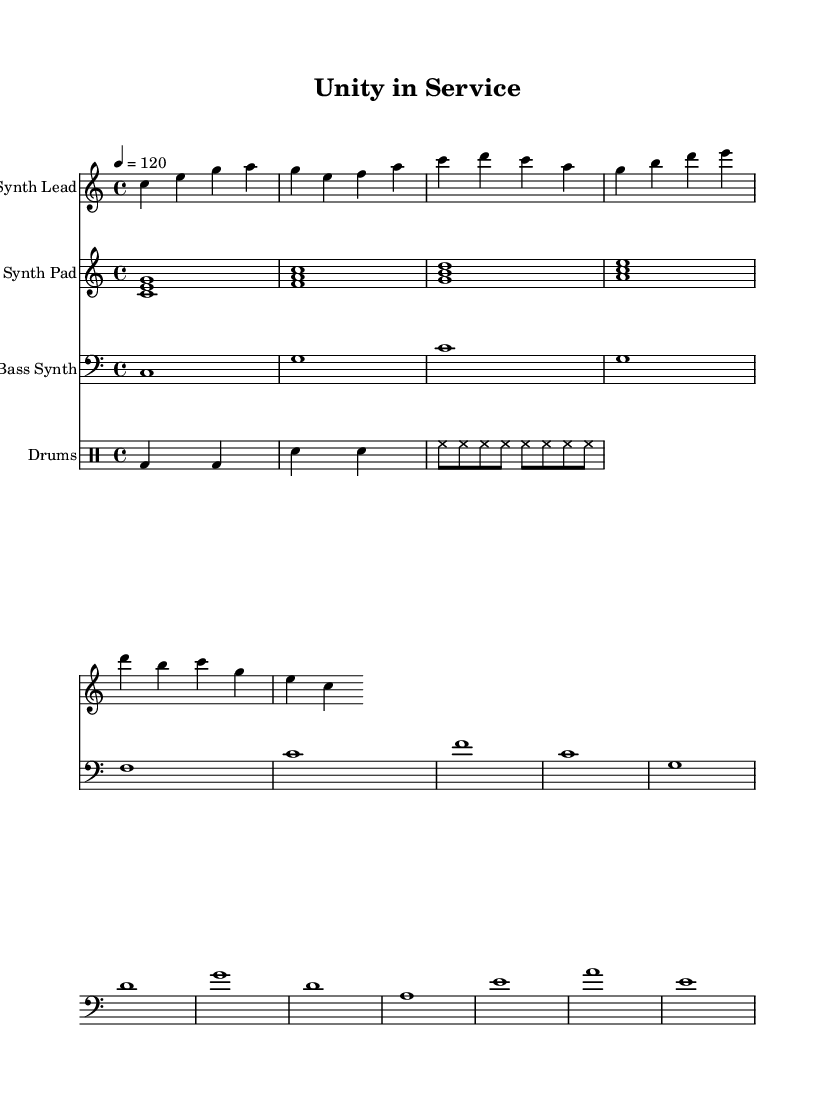What is the key signature of this music? The key signature is C major, which has no sharps or flats.
Answer: C major What is the time signature of this music? The time signature is indicated by the "4/4" notation, meaning there are 4 beats in a measure.
Answer: 4/4 What is the tempo marking for this piece? The tempo is marked as "4 = 120," indicating a speed of 120 beats per minute.
Answer: 120 How many different instruments are used in this composition? The score includes four different instruments: Synth Lead, Synth Pad, Bass Synth, and Drums.
Answer: Four Which section features chords played simultaneously? The Synth Pad section uses chord notation with simultaneous notes, indicated by brackets.
Answer: Synth Pad How does the bass synth pattern relate to the chord structure? The bass synth plays the root notes of each chord, which anchors the harmonic progression for the piece.
Answer: Root notes What type of rhythmic pattern is indicated by the drum section? The drum patterns use a standard dance rhythm, emphasizing bass and snare hits commonly found in electronic music styles.
Answer: Dance rhythm 